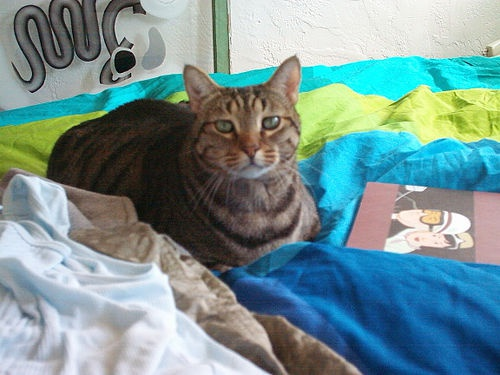Describe the objects in this image and their specific colors. I can see bed in darkgray, blue, lightgray, and cyan tones, cat in darkgray, black, gray, and maroon tones, and book in darkgray, lightpink, white, and gray tones in this image. 